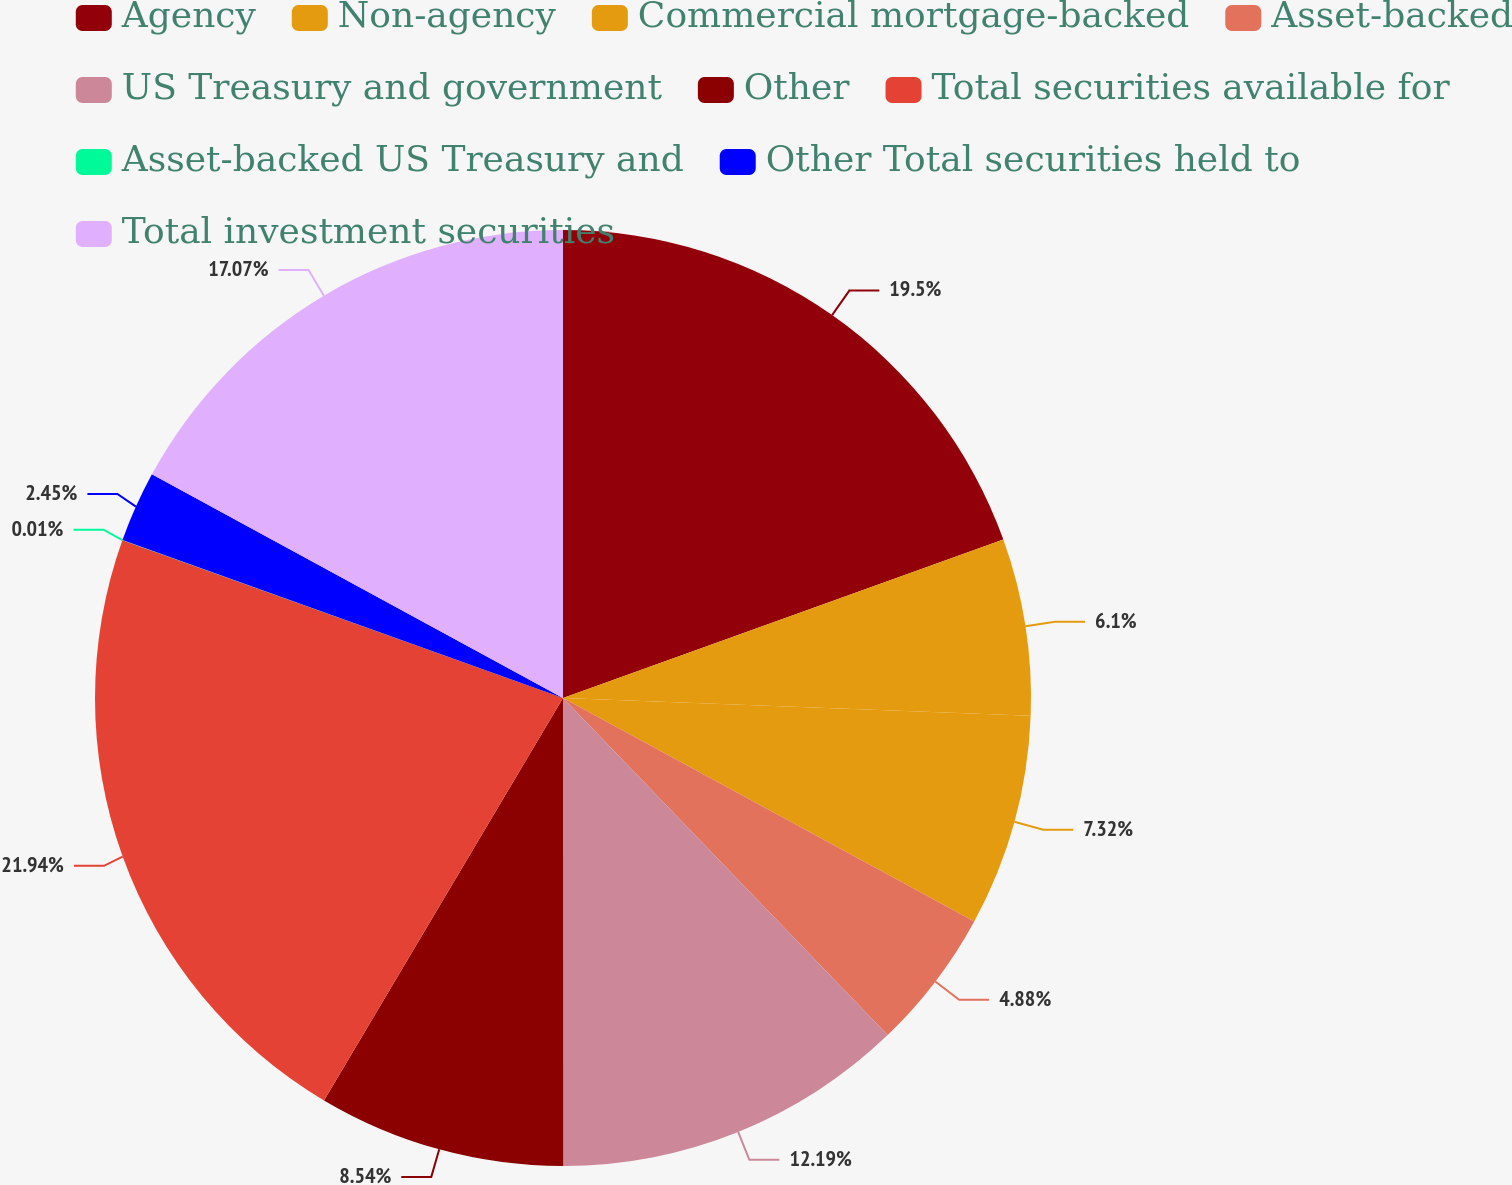Convert chart. <chart><loc_0><loc_0><loc_500><loc_500><pie_chart><fcel>Agency<fcel>Non-agency<fcel>Commercial mortgage-backed<fcel>Asset-backed<fcel>US Treasury and government<fcel>Other<fcel>Total securities available for<fcel>Asset-backed US Treasury and<fcel>Other Total securities held to<fcel>Total investment securities<nl><fcel>19.5%<fcel>6.1%<fcel>7.32%<fcel>4.88%<fcel>12.19%<fcel>8.54%<fcel>21.94%<fcel>0.01%<fcel>2.45%<fcel>17.07%<nl></chart> 